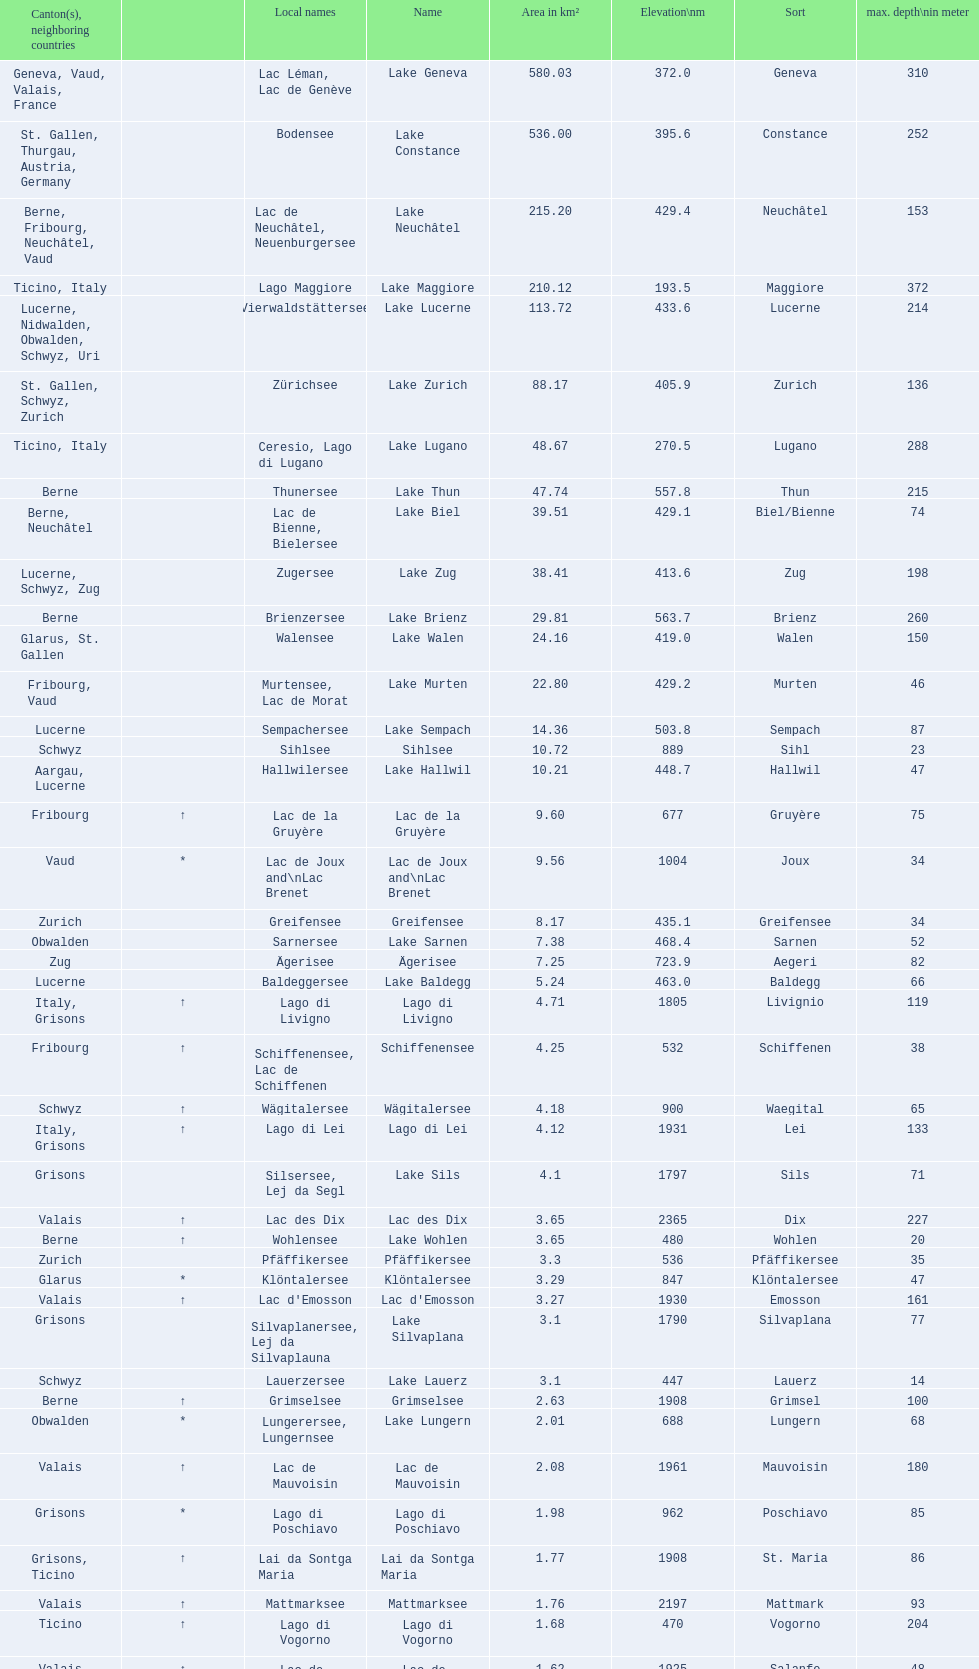Name the largest lake Lake Geneva. 